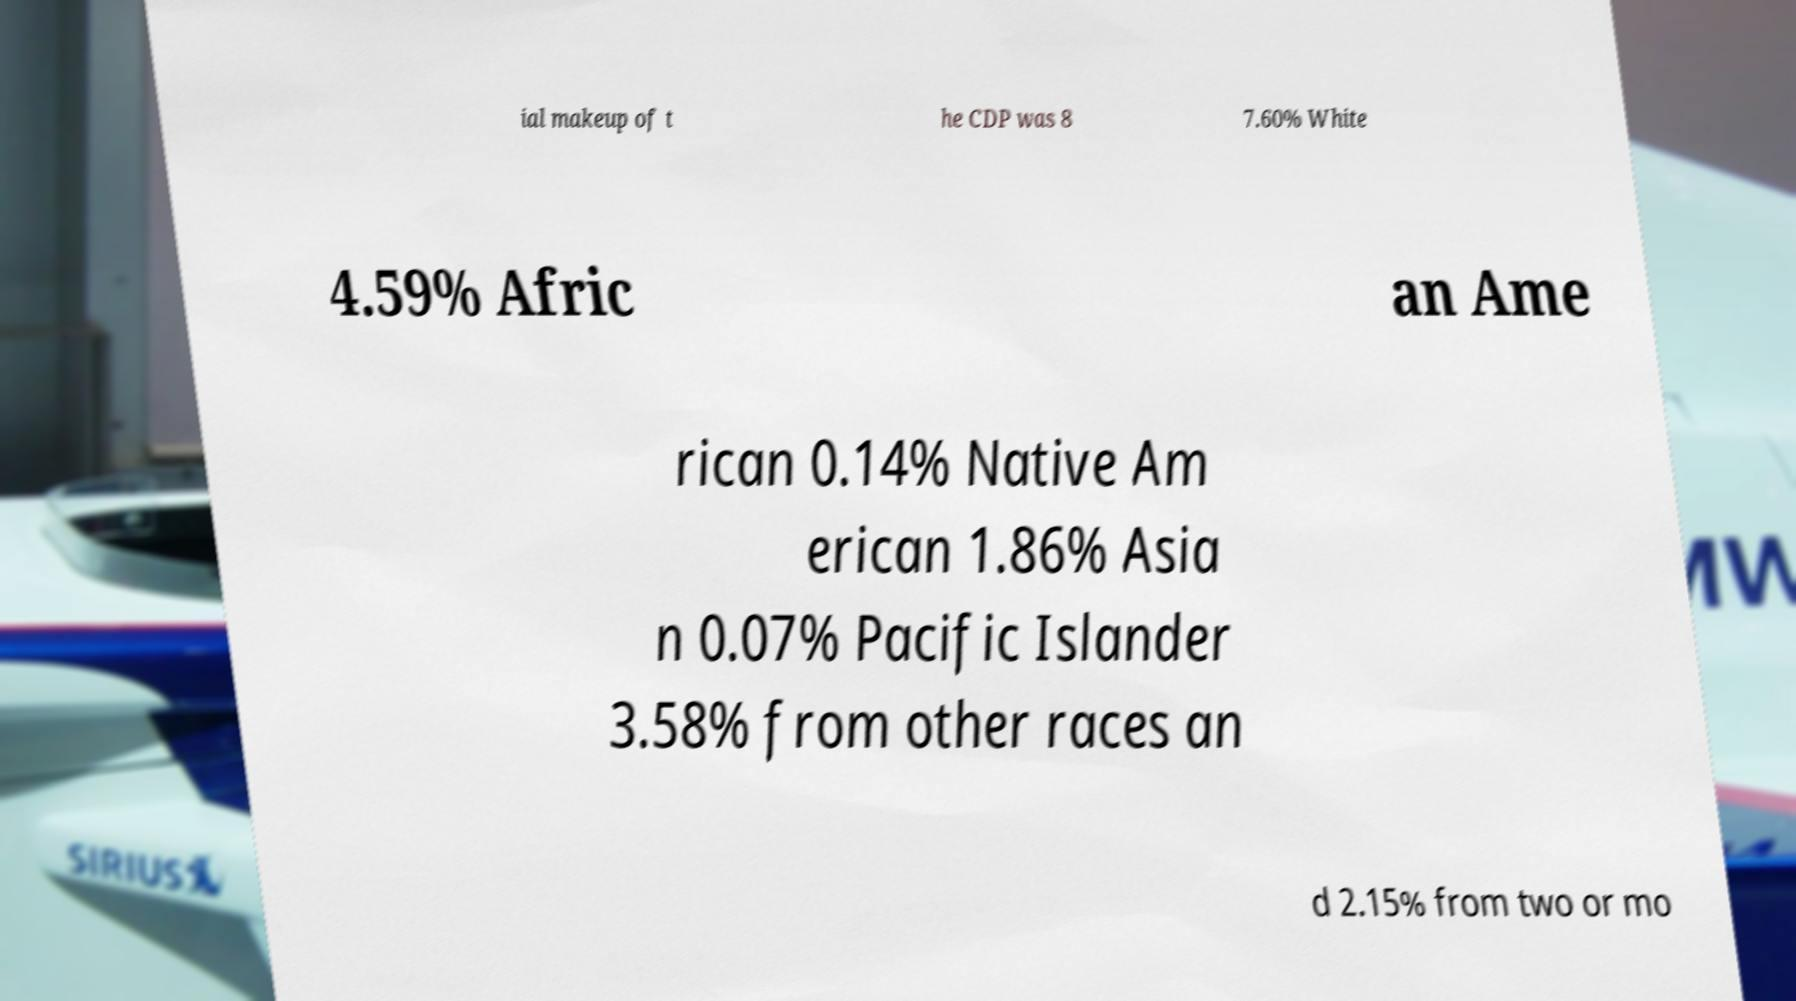Please identify and transcribe the text found in this image. ial makeup of t he CDP was 8 7.60% White 4.59% Afric an Ame rican 0.14% Native Am erican 1.86% Asia n 0.07% Pacific Islander 3.58% from other races an d 2.15% from two or mo 